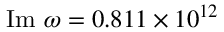<formula> <loc_0><loc_0><loc_500><loc_500>I m \omega = 0 . 8 1 1 \times 1 0 ^ { 1 2 }</formula> 